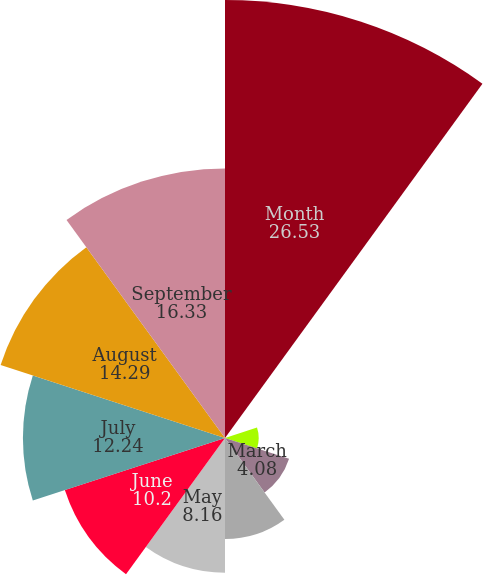Convert chart to OTSL. <chart><loc_0><loc_0><loc_500><loc_500><pie_chart><fcel>Month<fcel>January<fcel>February<fcel>March<fcel>April<fcel>May<fcel>June<fcel>July<fcel>August<fcel>September<nl><fcel>26.53%<fcel>0.0%<fcel>2.04%<fcel>4.08%<fcel>6.12%<fcel>8.16%<fcel>10.2%<fcel>12.24%<fcel>14.29%<fcel>16.33%<nl></chart> 